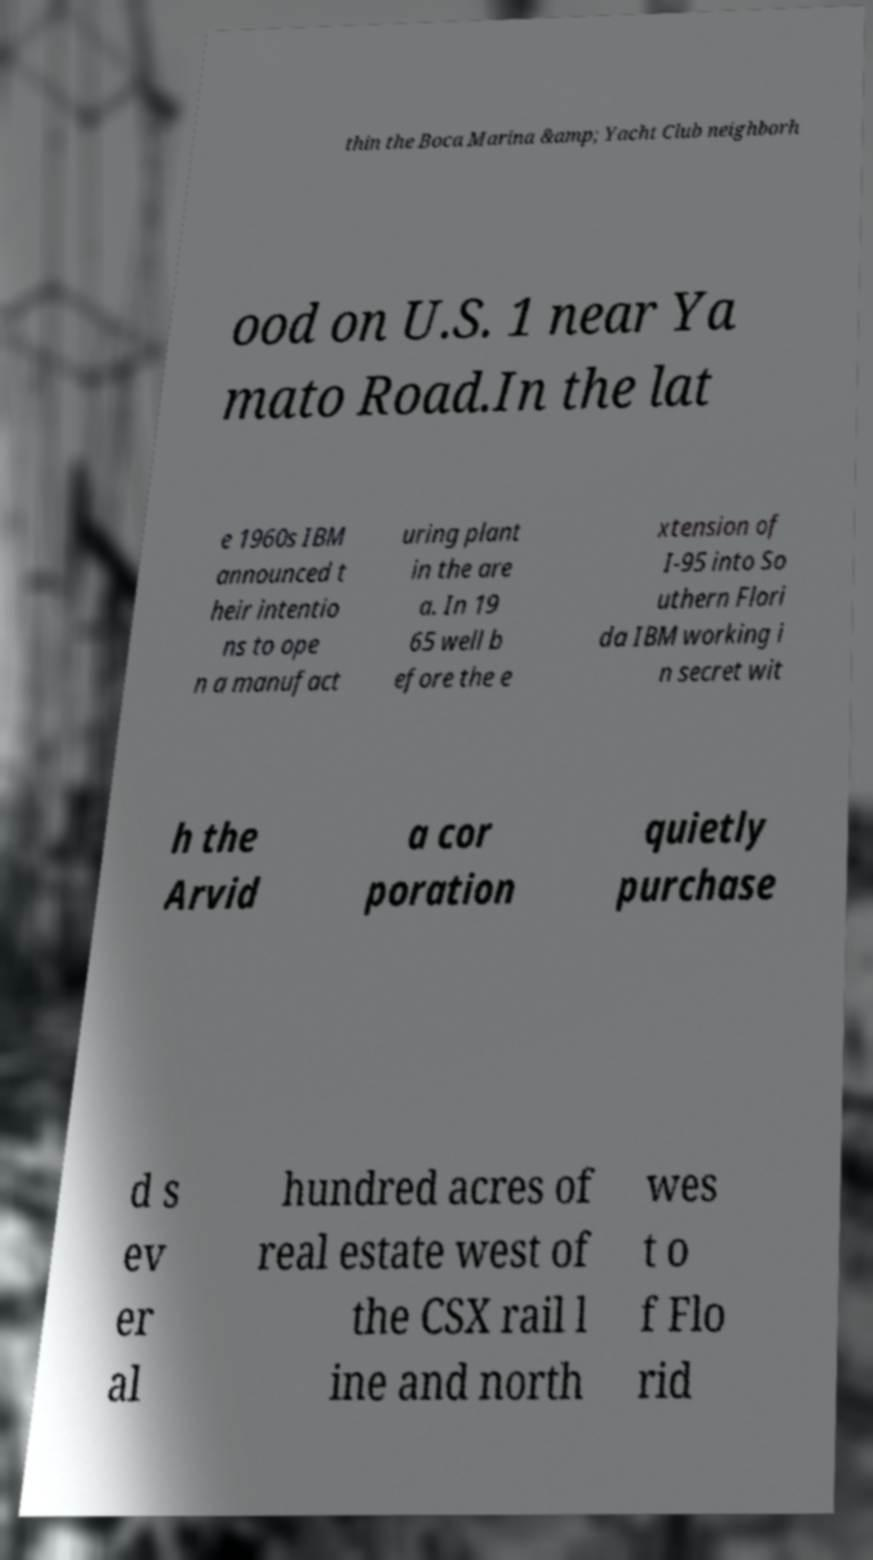Please read and relay the text visible in this image. What does it say? thin the Boca Marina &amp; Yacht Club neighborh ood on U.S. 1 near Ya mato Road.In the lat e 1960s IBM announced t heir intentio ns to ope n a manufact uring plant in the are a. In 19 65 well b efore the e xtension of I-95 into So uthern Flori da IBM working i n secret wit h the Arvid a cor poration quietly purchase d s ev er al hundred acres of real estate west of the CSX rail l ine and north wes t o f Flo rid 